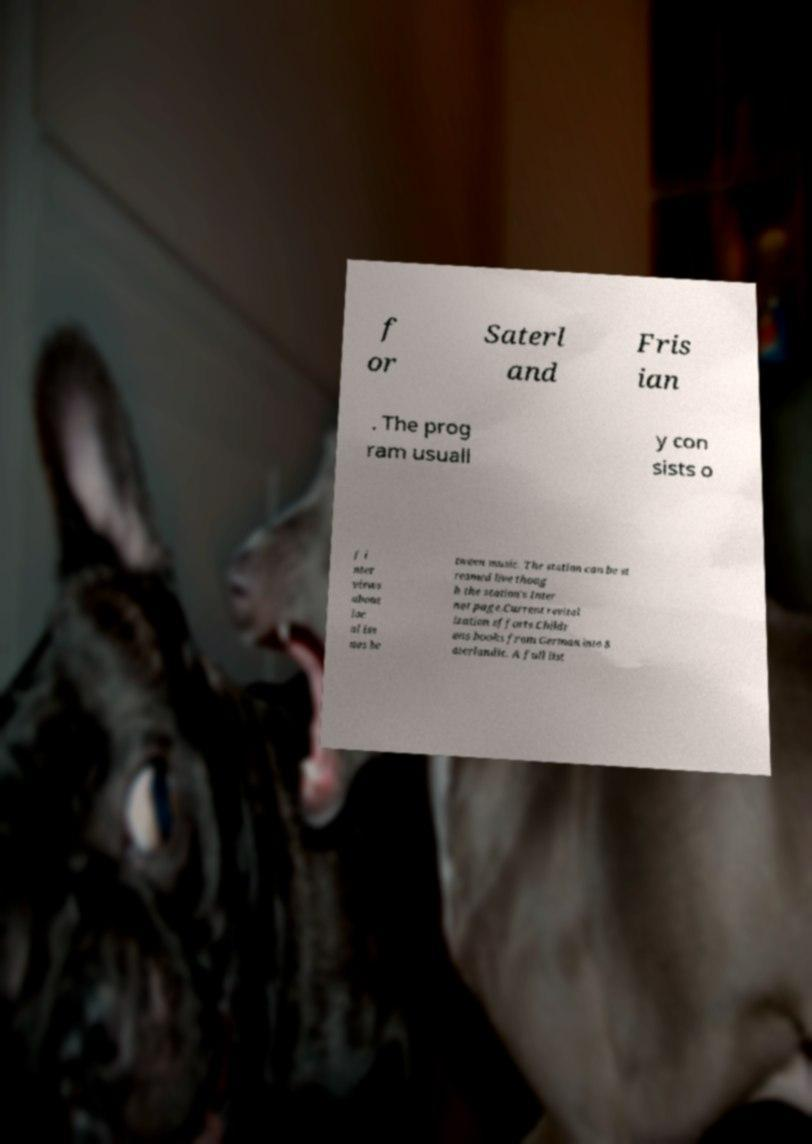Can you read and provide the text displayed in the image?This photo seems to have some interesting text. Can you extract and type it out for me? f or Saterl and Fris ian . The prog ram usuall y con sists o f i nter views about loc al iss ues be tween music. The station can be st reamed live thoug h the station's Inter net page.Current revital ization efforts.Childr ens books from German into S aterlandic. A full list 